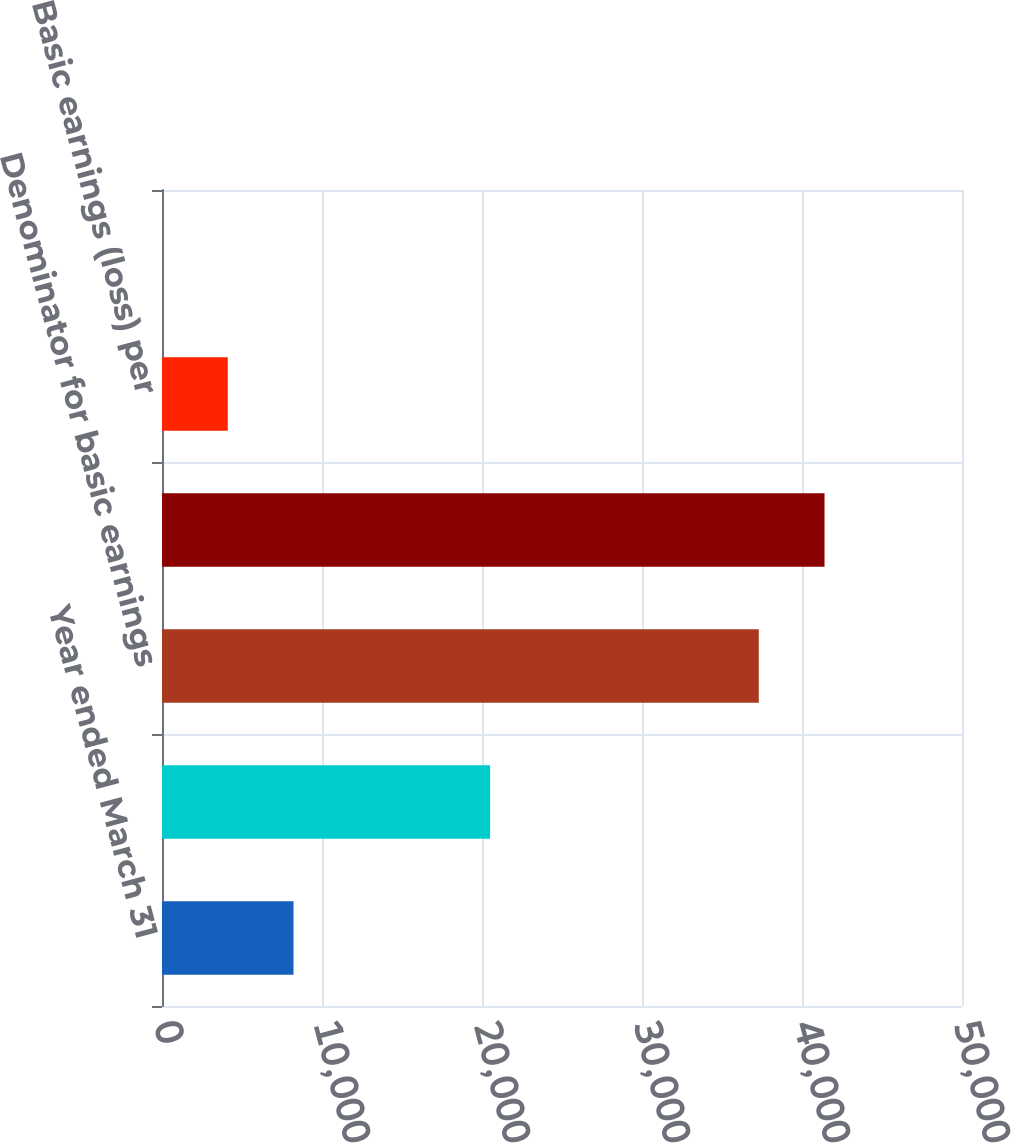<chart> <loc_0><loc_0><loc_500><loc_500><bar_chart><fcel>Year ended March 31<fcel>Numerator for basic and<fcel>Denominator for basic earnings<fcel>Denominator for diluted<fcel>Basic earnings (loss) per<fcel>Diluted earnings (loss) per<nl><fcel>8220.4<fcel>20507<fcel>37298<fcel>41407.9<fcel>4110.45<fcel>0.5<nl></chart> 